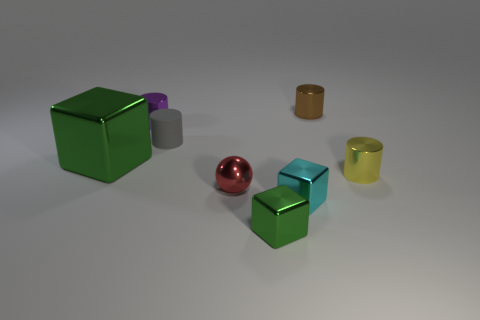What time of day does the lighting in the image suggest? The lighting in the image is diffused and non-directional, which does not indicate a particular time of day. It resembles studio lighting which can be used to uniformly light objects for clear visibility. 